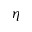<formula> <loc_0><loc_0><loc_500><loc_500>\eta</formula> 